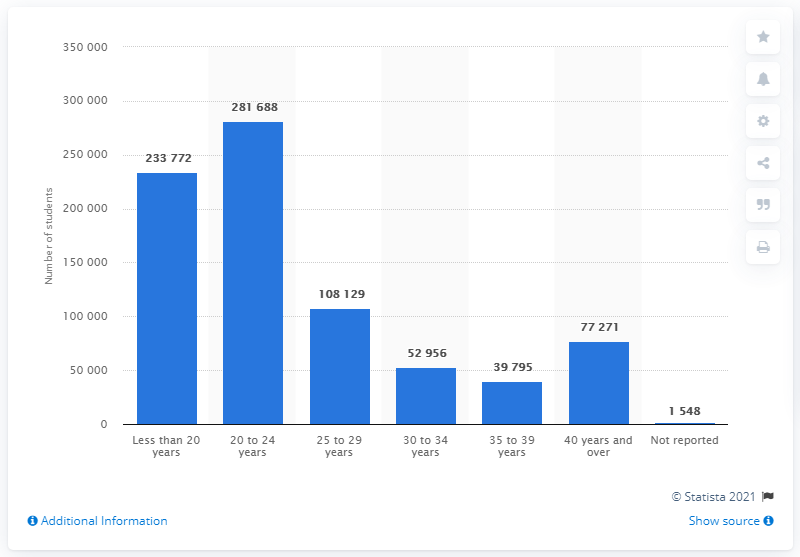Point out several critical features in this image. In Canada, there were a total of 281,688 students between the age group of 20 to 24 years who were enrolled in colleges as of 2021. The minimum number of students enrolled in a certain age group is less than the maximum number of students of the same age group. Specifically, the difference between the maximum number of 280,140 students of a certain age group and the minimum number of students enrolled in the same age group is 280,140 students. 